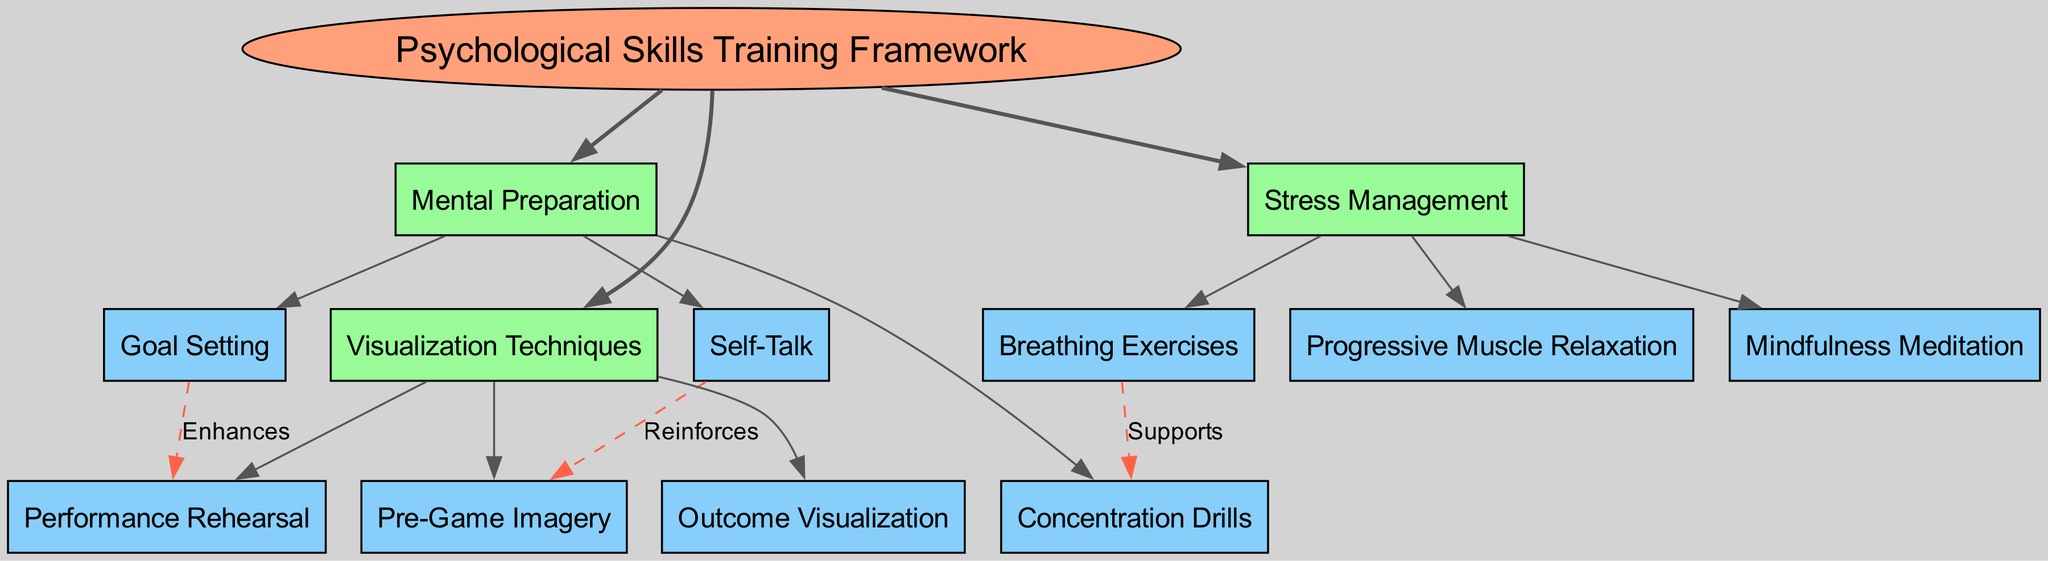What is the central node of the diagram? The central node, indicated by its position at the center of the diagram, is labeled "Psychological Skills Training Framework."
Answer: Psychological Skills Training Framework How many main branches are there? By counting the number of main branches stemming from the central node, we find three branches: Mental Preparation, Visualization Techniques, and Stress Management.
Answer: 3 What are the sub-branches under Stress Management? The sub-branches listed under Stress Management include Progressive Muscle Relaxation, Breathing Exercises, and Mindfulness Meditation.
Answer: Progressive Muscle Relaxation, Breathing Exercises, Mindfulness Meditation Which technique is connected to Concentration Drills? Concentration Drills is connected to Breathing Exercises, which supports it as indicated by the dashed line and labeled connection in the diagram.
Answer: Breathing Exercises What relationship does Goal Setting have with Performance Rehearsal? The diagram indicates that Goal Setting enhances Performance Rehearsal, as shown by the dashed line labeled "Enhances" connecting the two nodes.
Answer: Enhances How many connections are depicted in the diagram? Counting the labeled connections drawn between specific nodes, there are three connections: Goal Setting to Performance Rehearsal, Self-Talk to Pre-Game Imagery, and Breathing Exercises to Concentration Drills.
Answer: 3 Which visualization technique is reinforced by Self-Talk? The diagram shows that Pre-Game Imagery is the technique that is reinforced by Self-Talk, as indicated by the dashed connection between them labeled "Reinforces."
Answer: Pre-Game Imagery What supports Concentration Drills according to the diagram? The diagram states that Breathing Exercises supports Concentration Drills, connected by a dashed line with the label "Supports."
Answer: Breathing Exercises How many sub-branches does Mental Preparation have? By checking the sub-branches under Mental Preparation, we see three items listed: Goal Setting, Self-Talk, and Concentration Drills.
Answer: 3 